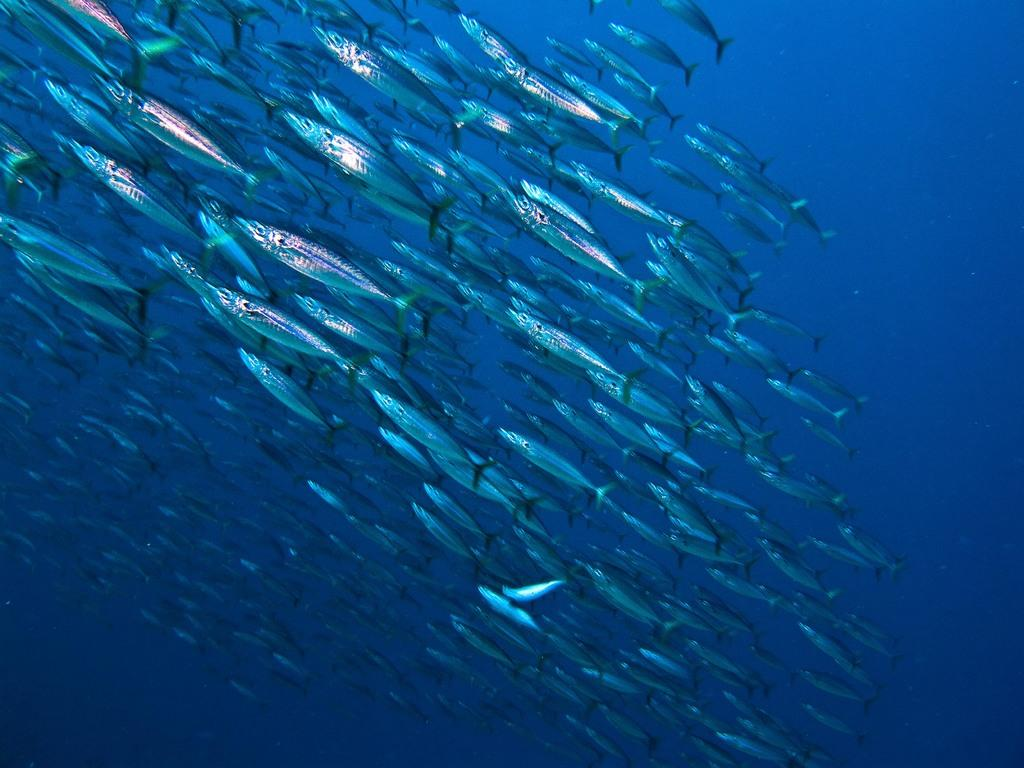What type of animals are in the image? There is a group of fishes in the image. Where are the fishes located? The fishes are in water. What type of snack is being shared among the fishes in the image? There is no snack, such as popcorn, present in the image. The fishes are in water, and they do not consume popcorn. 